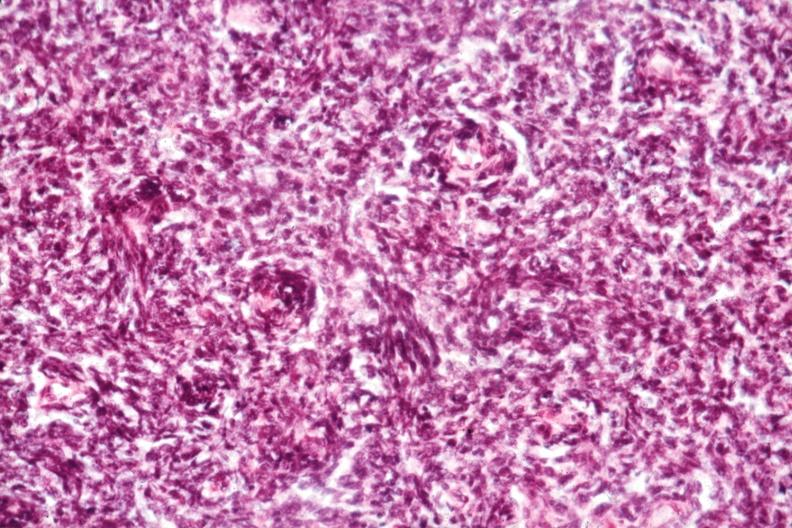what is present?
Answer the question using a single word or phrase. Hematologic 